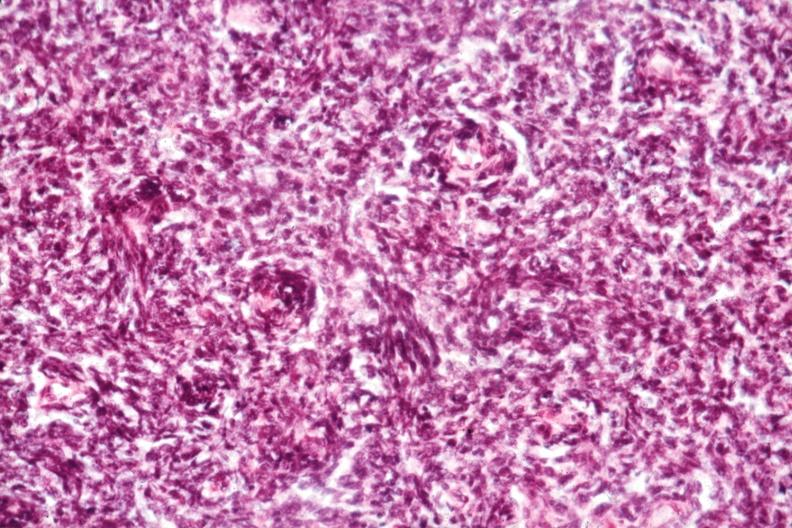what is present?
Answer the question using a single word or phrase. Hematologic 